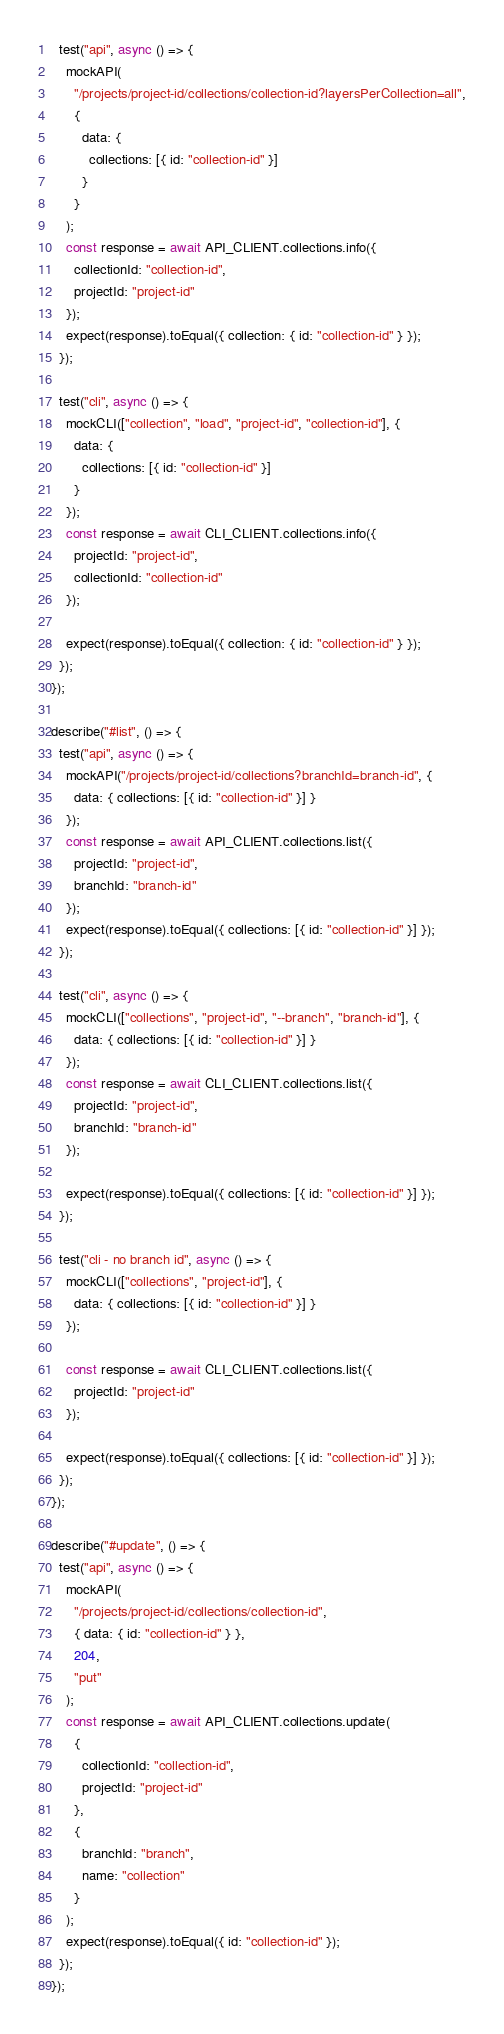<code> <loc_0><loc_0><loc_500><loc_500><_JavaScript_>  test("api", async () => {
    mockAPI(
      "/projects/project-id/collections/collection-id?layersPerCollection=all",
      {
        data: {
          collections: [{ id: "collection-id" }]
        }
      }
    );
    const response = await API_CLIENT.collections.info({
      collectionId: "collection-id",
      projectId: "project-id"
    });
    expect(response).toEqual({ collection: { id: "collection-id" } });
  });

  test("cli", async () => {
    mockCLI(["collection", "load", "project-id", "collection-id"], {
      data: {
        collections: [{ id: "collection-id" }]
      }
    });
    const response = await CLI_CLIENT.collections.info({
      projectId: "project-id",
      collectionId: "collection-id"
    });

    expect(response).toEqual({ collection: { id: "collection-id" } });
  });
});

describe("#list", () => {
  test("api", async () => {
    mockAPI("/projects/project-id/collections?branchId=branch-id", {
      data: { collections: [{ id: "collection-id" }] }
    });
    const response = await API_CLIENT.collections.list({
      projectId: "project-id",
      branchId: "branch-id"
    });
    expect(response).toEqual({ collections: [{ id: "collection-id" }] });
  });

  test("cli", async () => {
    mockCLI(["collections", "project-id", "--branch", "branch-id"], {
      data: { collections: [{ id: "collection-id" }] }
    });
    const response = await CLI_CLIENT.collections.list({
      projectId: "project-id",
      branchId: "branch-id"
    });

    expect(response).toEqual({ collections: [{ id: "collection-id" }] });
  });

  test("cli - no branch id", async () => {
    mockCLI(["collections", "project-id"], {
      data: { collections: [{ id: "collection-id" }] }
    });

    const response = await CLI_CLIENT.collections.list({
      projectId: "project-id"
    });

    expect(response).toEqual({ collections: [{ id: "collection-id" }] });
  });
});

describe("#update", () => {
  test("api", async () => {
    mockAPI(
      "/projects/project-id/collections/collection-id",
      { data: { id: "collection-id" } },
      204,
      "put"
    );
    const response = await API_CLIENT.collections.update(
      {
        collectionId: "collection-id",
        projectId: "project-id"
      },
      {
        branchId: "branch",
        name: "collection"
      }
    );
    expect(response).toEqual({ id: "collection-id" });
  });
});
</code> 